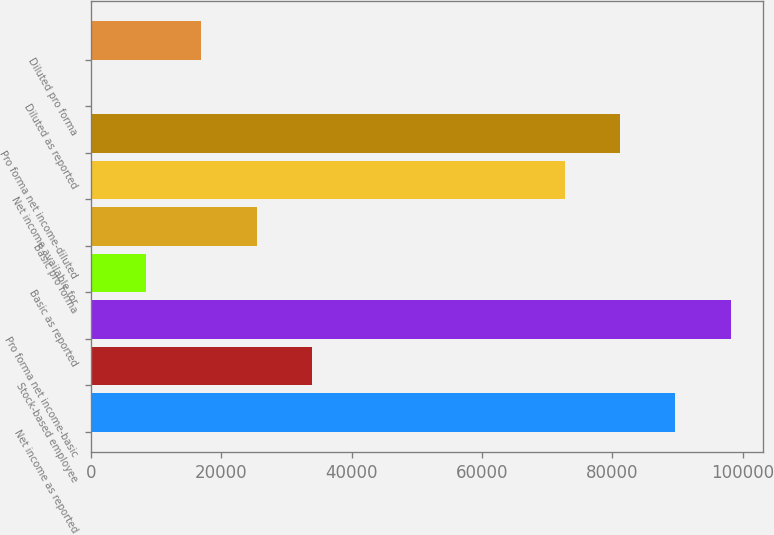Convert chart. <chart><loc_0><loc_0><loc_500><loc_500><bar_chart><fcel>Net income as reported<fcel>Stock-based employee<fcel>Pro forma net income-basic<fcel>Basic as reported<fcel>Basic pro forma<fcel>Net income available for<fcel>Pro forma net income-diluted<fcel>Diluted as reported<fcel>Diluted pro forma<nl><fcel>89651.3<fcel>33942.1<fcel>98136.5<fcel>8486.57<fcel>25456.9<fcel>72681<fcel>81166.2<fcel>1.41<fcel>16971.7<nl></chart> 